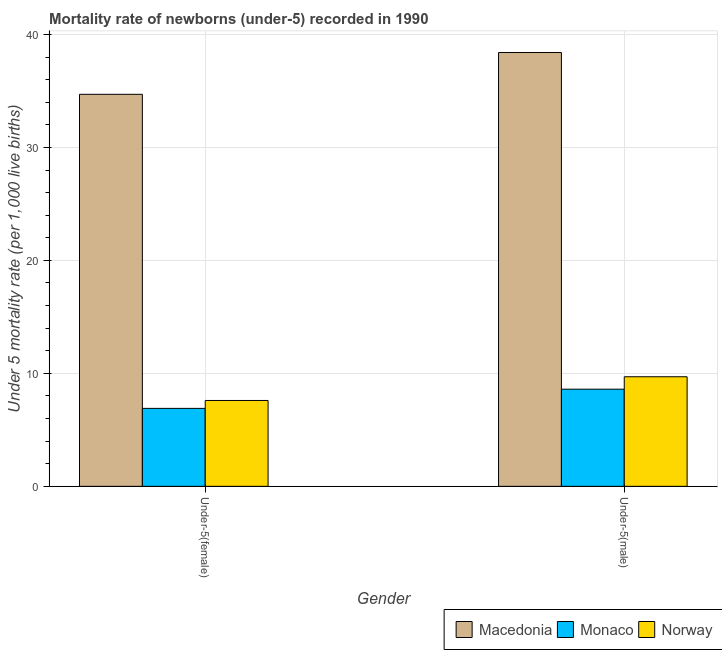How many bars are there on the 1st tick from the left?
Your answer should be compact. 3. How many bars are there on the 2nd tick from the right?
Make the answer very short. 3. What is the label of the 1st group of bars from the left?
Offer a terse response. Under-5(female). Across all countries, what is the maximum under-5 female mortality rate?
Make the answer very short. 34.7. Across all countries, what is the minimum under-5 female mortality rate?
Your answer should be very brief. 6.9. In which country was the under-5 female mortality rate maximum?
Keep it short and to the point. Macedonia. In which country was the under-5 male mortality rate minimum?
Keep it short and to the point. Monaco. What is the total under-5 female mortality rate in the graph?
Offer a very short reply. 49.2. What is the difference between the under-5 male mortality rate in Monaco and that in Macedonia?
Offer a terse response. -29.8. What is the difference between the under-5 female mortality rate in Macedonia and the under-5 male mortality rate in Monaco?
Make the answer very short. 26.1. What is the average under-5 female mortality rate per country?
Offer a very short reply. 16.4. What is the difference between the under-5 male mortality rate and under-5 female mortality rate in Monaco?
Give a very brief answer. 1.7. In how many countries, is the under-5 female mortality rate greater than 12 ?
Ensure brevity in your answer.  1. What is the ratio of the under-5 female mortality rate in Norway to that in Macedonia?
Give a very brief answer. 0.22. In how many countries, is the under-5 male mortality rate greater than the average under-5 male mortality rate taken over all countries?
Make the answer very short. 1. What does the 1st bar from the left in Under-5(male) represents?
Your answer should be very brief. Macedonia. What does the 1st bar from the right in Under-5(male) represents?
Keep it short and to the point. Norway. What is the difference between two consecutive major ticks on the Y-axis?
Your answer should be very brief. 10. Does the graph contain any zero values?
Offer a very short reply. No. Does the graph contain grids?
Your response must be concise. Yes. How many legend labels are there?
Offer a very short reply. 3. What is the title of the graph?
Provide a short and direct response. Mortality rate of newborns (under-5) recorded in 1990. What is the label or title of the Y-axis?
Your answer should be compact. Under 5 mortality rate (per 1,0 live births). What is the Under 5 mortality rate (per 1,000 live births) of Macedonia in Under-5(female)?
Your response must be concise. 34.7. What is the Under 5 mortality rate (per 1,000 live births) of Monaco in Under-5(female)?
Your answer should be compact. 6.9. What is the Under 5 mortality rate (per 1,000 live births) in Norway in Under-5(female)?
Give a very brief answer. 7.6. What is the Under 5 mortality rate (per 1,000 live births) in Macedonia in Under-5(male)?
Give a very brief answer. 38.4. Across all Gender, what is the maximum Under 5 mortality rate (per 1,000 live births) in Macedonia?
Keep it short and to the point. 38.4. Across all Gender, what is the minimum Under 5 mortality rate (per 1,000 live births) in Macedonia?
Provide a succinct answer. 34.7. Across all Gender, what is the minimum Under 5 mortality rate (per 1,000 live births) in Monaco?
Provide a short and direct response. 6.9. What is the total Under 5 mortality rate (per 1,000 live births) of Macedonia in the graph?
Keep it short and to the point. 73.1. What is the difference between the Under 5 mortality rate (per 1,000 live births) of Macedonia in Under-5(female) and that in Under-5(male)?
Your answer should be compact. -3.7. What is the difference between the Under 5 mortality rate (per 1,000 live births) of Monaco in Under-5(female) and that in Under-5(male)?
Provide a succinct answer. -1.7. What is the difference between the Under 5 mortality rate (per 1,000 live births) of Norway in Under-5(female) and that in Under-5(male)?
Provide a short and direct response. -2.1. What is the difference between the Under 5 mortality rate (per 1,000 live births) of Macedonia in Under-5(female) and the Under 5 mortality rate (per 1,000 live births) of Monaco in Under-5(male)?
Ensure brevity in your answer.  26.1. What is the difference between the Under 5 mortality rate (per 1,000 live births) in Macedonia in Under-5(female) and the Under 5 mortality rate (per 1,000 live births) in Norway in Under-5(male)?
Provide a succinct answer. 25. What is the average Under 5 mortality rate (per 1,000 live births) of Macedonia per Gender?
Ensure brevity in your answer.  36.55. What is the average Under 5 mortality rate (per 1,000 live births) in Monaco per Gender?
Ensure brevity in your answer.  7.75. What is the average Under 5 mortality rate (per 1,000 live births) of Norway per Gender?
Your answer should be compact. 8.65. What is the difference between the Under 5 mortality rate (per 1,000 live births) of Macedonia and Under 5 mortality rate (per 1,000 live births) of Monaco in Under-5(female)?
Offer a terse response. 27.8. What is the difference between the Under 5 mortality rate (per 1,000 live births) of Macedonia and Under 5 mortality rate (per 1,000 live births) of Norway in Under-5(female)?
Give a very brief answer. 27.1. What is the difference between the Under 5 mortality rate (per 1,000 live births) of Monaco and Under 5 mortality rate (per 1,000 live births) of Norway in Under-5(female)?
Offer a very short reply. -0.7. What is the difference between the Under 5 mortality rate (per 1,000 live births) in Macedonia and Under 5 mortality rate (per 1,000 live births) in Monaco in Under-5(male)?
Offer a very short reply. 29.8. What is the difference between the Under 5 mortality rate (per 1,000 live births) of Macedonia and Under 5 mortality rate (per 1,000 live births) of Norway in Under-5(male)?
Provide a succinct answer. 28.7. What is the difference between the Under 5 mortality rate (per 1,000 live births) in Monaco and Under 5 mortality rate (per 1,000 live births) in Norway in Under-5(male)?
Your response must be concise. -1.1. What is the ratio of the Under 5 mortality rate (per 1,000 live births) in Macedonia in Under-5(female) to that in Under-5(male)?
Provide a short and direct response. 0.9. What is the ratio of the Under 5 mortality rate (per 1,000 live births) of Monaco in Under-5(female) to that in Under-5(male)?
Give a very brief answer. 0.8. What is the ratio of the Under 5 mortality rate (per 1,000 live births) in Norway in Under-5(female) to that in Under-5(male)?
Offer a very short reply. 0.78. What is the difference between the highest and the second highest Under 5 mortality rate (per 1,000 live births) in Macedonia?
Make the answer very short. 3.7. What is the difference between the highest and the second highest Under 5 mortality rate (per 1,000 live births) of Norway?
Your response must be concise. 2.1. What is the difference between the highest and the lowest Under 5 mortality rate (per 1,000 live births) in Macedonia?
Your answer should be very brief. 3.7. 